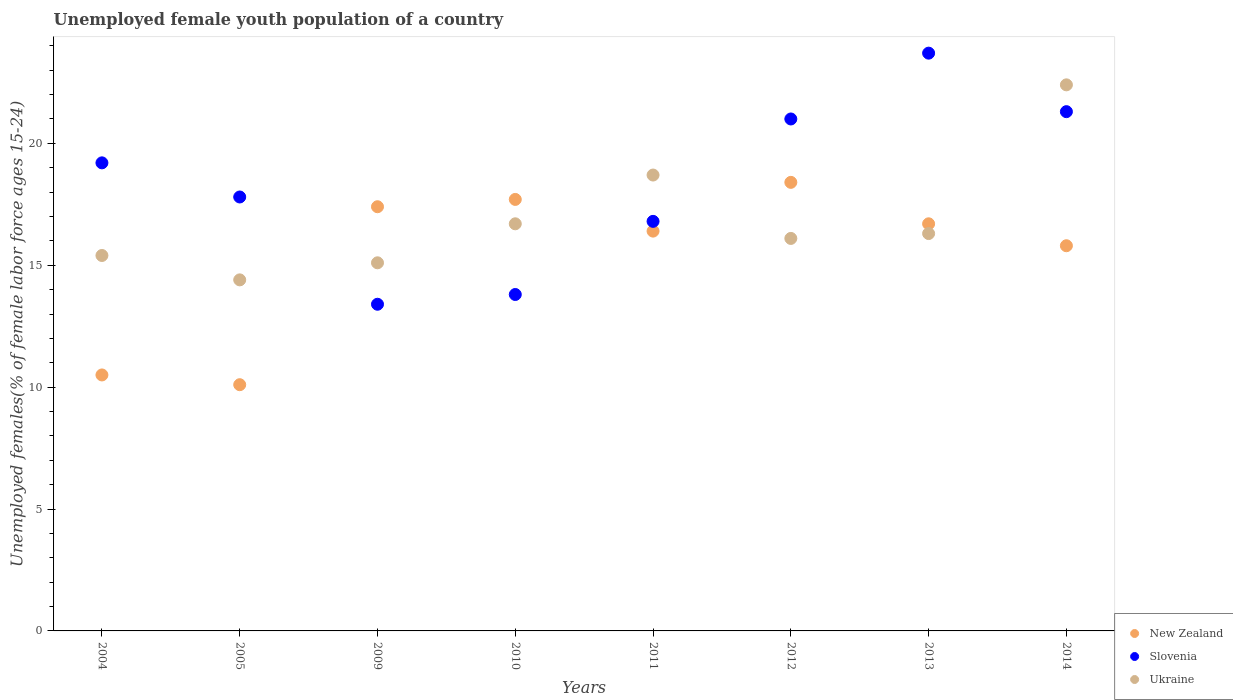How many different coloured dotlines are there?
Keep it short and to the point. 3. Is the number of dotlines equal to the number of legend labels?
Your answer should be very brief. Yes. What is the percentage of unemployed female youth population in Ukraine in 2013?
Give a very brief answer. 16.3. Across all years, what is the maximum percentage of unemployed female youth population in Slovenia?
Offer a terse response. 23.7. Across all years, what is the minimum percentage of unemployed female youth population in Slovenia?
Keep it short and to the point. 13.4. In which year was the percentage of unemployed female youth population in Slovenia maximum?
Provide a succinct answer. 2013. What is the total percentage of unemployed female youth population in Slovenia in the graph?
Give a very brief answer. 147. What is the difference between the percentage of unemployed female youth population in New Zealand in 2004 and that in 2011?
Your answer should be compact. -5.9. What is the difference between the percentage of unemployed female youth population in New Zealand in 2012 and the percentage of unemployed female youth population in Slovenia in 2010?
Give a very brief answer. 4.6. What is the average percentage of unemployed female youth population in New Zealand per year?
Keep it short and to the point. 15.38. In the year 2010, what is the difference between the percentage of unemployed female youth population in New Zealand and percentage of unemployed female youth population in Ukraine?
Provide a short and direct response. 1. In how many years, is the percentage of unemployed female youth population in Ukraine greater than 17 %?
Your answer should be compact. 2. What is the ratio of the percentage of unemployed female youth population in Ukraine in 2009 to that in 2012?
Give a very brief answer. 0.94. Is the percentage of unemployed female youth population in Ukraine in 2009 less than that in 2013?
Give a very brief answer. Yes. What is the difference between the highest and the second highest percentage of unemployed female youth population in Ukraine?
Your answer should be compact. 3.7. What is the difference between the highest and the lowest percentage of unemployed female youth population in New Zealand?
Your response must be concise. 8.3. Is the sum of the percentage of unemployed female youth population in Slovenia in 2012 and 2014 greater than the maximum percentage of unemployed female youth population in New Zealand across all years?
Ensure brevity in your answer.  Yes. Does the percentage of unemployed female youth population in Slovenia monotonically increase over the years?
Give a very brief answer. No. How many dotlines are there?
Provide a short and direct response. 3. Does the graph contain grids?
Your response must be concise. No. Where does the legend appear in the graph?
Your response must be concise. Bottom right. How are the legend labels stacked?
Keep it short and to the point. Vertical. What is the title of the graph?
Your response must be concise. Unemployed female youth population of a country. Does "Belize" appear as one of the legend labels in the graph?
Keep it short and to the point. No. What is the label or title of the X-axis?
Your answer should be very brief. Years. What is the label or title of the Y-axis?
Provide a succinct answer. Unemployed females(% of female labor force ages 15-24). What is the Unemployed females(% of female labor force ages 15-24) of New Zealand in 2004?
Offer a terse response. 10.5. What is the Unemployed females(% of female labor force ages 15-24) in Slovenia in 2004?
Offer a very short reply. 19.2. What is the Unemployed females(% of female labor force ages 15-24) of Ukraine in 2004?
Provide a succinct answer. 15.4. What is the Unemployed females(% of female labor force ages 15-24) of New Zealand in 2005?
Your answer should be compact. 10.1. What is the Unemployed females(% of female labor force ages 15-24) of Slovenia in 2005?
Give a very brief answer. 17.8. What is the Unemployed females(% of female labor force ages 15-24) of Ukraine in 2005?
Provide a succinct answer. 14.4. What is the Unemployed females(% of female labor force ages 15-24) of New Zealand in 2009?
Provide a short and direct response. 17.4. What is the Unemployed females(% of female labor force ages 15-24) of Slovenia in 2009?
Your answer should be very brief. 13.4. What is the Unemployed females(% of female labor force ages 15-24) of Ukraine in 2009?
Your response must be concise. 15.1. What is the Unemployed females(% of female labor force ages 15-24) of New Zealand in 2010?
Offer a terse response. 17.7. What is the Unemployed females(% of female labor force ages 15-24) of Slovenia in 2010?
Keep it short and to the point. 13.8. What is the Unemployed females(% of female labor force ages 15-24) in Ukraine in 2010?
Offer a terse response. 16.7. What is the Unemployed females(% of female labor force ages 15-24) of New Zealand in 2011?
Your response must be concise. 16.4. What is the Unemployed females(% of female labor force ages 15-24) in Slovenia in 2011?
Your answer should be very brief. 16.8. What is the Unemployed females(% of female labor force ages 15-24) of Ukraine in 2011?
Provide a succinct answer. 18.7. What is the Unemployed females(% of female labor force ages 15-24) in New Zealand in 2012?
Give a very brief answer. 18.4. What is the Unemployed females(% of female labor force ages 15-24) in Ukraine in 2012?
Offer a terse response. 16.1. What is the Unemployed females(% of female labor force ages 15-24) of New Zealand in 2013?
Your answer should be compact. 16.7. What is the Unemployed females(% of female labor force ages 15-24) of Slovenia in 2013?
Provide a short and direct response. 23.7. What is the Unemployed females(% of female labor force ages 15-24) of Ukraine in 2013?
Your answer should be compact. 16.3. What is the Unemployed females(% of female labor force ages 15-24) in New Zealand in 2014?
Provide a short and direct response. 15.8. What is the Unemployed females(% of female labor force ages 15-24) in Slovenia in 2014?
Your answer should be compact. 21.3. What is the Unemployed females(% of female labor force ages 15-24) in Ukraine in 2014?
Offer a terse response. 22.4. Across all years, what is the maximum Unemployed females(% of female labor force ages 15-24) in New Zealand?
Provide a succinct answer. 18.4. Across all years, what is the maximum Unemployed females(% of female labor force ages 15-24) of Slovenia?
Offer a very short reply. 23.7. Across all years, what is the maximum Unemployed females(% of female labor force ages 15-24) of Ukraine?
Make the answer very short. 22.4. Across all years, what is the minimum Unemployed females(% of female labor force ages 15-24) in New Zealand?
Your response must be concise. 10.1. Across all years, what is the minimum Unemployed females(% of female labor force ages 15-24) in Slovenia?
Offer a very short reply. 13.4. Across all years, what is the minimum Unemployed females(% of female labor force ages 15-24) of Ukraine?
Provide a succinct answer. 14.4. What is the total Unemployed females(% of female labor force ages 15-24) of New Zealand in the graph?
Offer a terse response. 123. What is the total Unemployed females(% of female labor force ages 15-24) in Slovenia in the graph?
Keep it short and to the point. 147. What is the total Unemployed females(% of female labor force ages 15-24) in Ukraine in the graph?
Ensure brevity in your answer.  135.1. What is the difference between the Unemployed females(% of female labor force ages 15-24) in Slovenia in 2004 and that in 2010?
Make the answer very short. 5.4. What is the difference between the Unemployed females(% of female labor force ages 15-24) in Slovenia in 2004 and that in 2012?
Offer a very short reply. -1.8. What is the difference between the Unemployed females(% of female labor force ages 15-24) of New Zealand in 2004 and that in 2013?
Offer a very short reply. -6.2. What is the difference between the Unemployed females(% of female labor force ages 15-24) in Slovenia in 2004 and that in 2013?
Ensure brevity in your answer.  -4.5. What is the difference between the Unemployed females(% of female labor force ages 15-24) of Ukraine in 2004 and that in 2013?
Give a very brief answer. -0.9. What is the difference between the Unemployed females(% of female labor force ages 15-24) in New Zealand in 2004 and that in 2014?
Offer a terse response. -5.3. What is the difference between the Unemployed females(% of female labor force ages 15-24) in Ukraine in 2004 and that in 2014?
Provide a succinct answer. -7. What is the difference between the Unemployed females(% of female labor force ages 15-24) of New Zealand in 2005 and that in 2009?
Ensure brevity in your answer.  -7.3. What is the difference between the Unemployed females(% of female labor force ages 15-24) in New Zealand in 2005 and that in 2010?
Your answer should be very brief. -7.6. What is the difference between the Unemployed females(% of female labor force ages 15-24) of Slovenia in 2005 and that in 2010?
Ensure brevity in your answer.  4. What is the difference between the Unemployed females(% of female labor force ages 15-24) in Slovenia in 2005 and that in 2011?
Provide a short and direct response. 1. What is the difference between the Unemployed females(% of female labor force ages 15-24) in Slovenia in 2005 and that in 2013?
Keep it short and to the point. -5.9. What is the difference between the Unemployed females(% of female labor force ages 15-24) of New Zealand in 2005 and that in 2014?
Make the answer very short. -5.7. What is the difference between the Unemployed females(% of female labor force ages 15-24) of Slovenia in 2005 and that in 2014?
Ensure brevity in your answer.  -3.5. What is the difference between the Unemployed females(% of female labor force ages 15-24) of Ukraine in 2005 and that in 2014?
Give a very brief answer. -8. What is the difference between the Unemployed females(% of female labor force ages 15-24) in Slovenia in 2009 and that in 2010?
Your response must be concise. -0.4. What is the difference between the Unemployed females(% of female labor force ages 15-24) in Ukraine in 2009 and that in 2011?
Keep it short and to the point. -3.6. What is the difference between the Unemployed females(% of female labor force ages 15-24) of New Zealand in 2009 and that in 2012?
Offer a very short reply. -1. What is the difference between the Unemployed females(% of female labor force ages 15-24) in New Zealand in 2009 and that in 2013?
Keep it short and to the point. 0.7. What is the difference between the Unemployed females(% of female labor force ages 15-24) in Slovenia in 2009 and that in 2013?
Give a very brief answer. -10.3. What is the difference between the Unemployed females(% of female labor force ages 15-24) in Slovenia in 2009 and that in 2014?
Your answer should be compact. -7.9. What is the difference between the Unemployed females(% of female labor force ages 15-24) of Ukraine in 2009 and that in 2014?
Provide a succinct answer. -7.3. What is the difference between the Unemployed females(% of female labor force ages 15-24) in Slovenia in 2010 and that in 2011?
Offer a very short reply. -3. What is the difference between the Unemployed females(% of female labor force ages 15-24) of New Zealand in 2010 and that in 2012?
Provide a succinct answer. -0.7. What is the difference between the Unemployed females(% of female labor force ages 15-24) of New Zealand in 2010 and that in 2013?
Provide a short and direct response. 1. What is the difference between the Unemployed females(% of female labor force ages 15-24) in Ukraine in 2010 and that in 2013?
Your response must be concise. 0.4. What is the difference between the Unemployed females(% of female labor force ages 15-24) of Slovenia in 2010 and that in 2014?
Keep it short and to the point. -7.5. What is the difference between the Unemployed females(% of female labor force ages 15-24) of Slovenia in 2011 and that in 2012?
Ensure brevity in your answer.  -4.2. What is the difference between the Unemployed females(% of female labor force ages 15-24) in Ukraine in 2011 and that in 2012?
Your answer should be very brief. 2.6. What is the difference between the Unemployed females(% of female labor force ages 15-24) in New Zealand in 2011 and that in 2013?
Make the answer very short. -0.3. What is the difference between the Unemployed females(% of female labor force ages 15-24) of Ukraine in 2011 and that in 2013?
Make the answer very short. 2.4. What is the difference between the Unemployed females(% of female labor force ages 15-24) in Ukraine in 2011 and that in 2014?
Make the answer very short. -3.7. What is the difference between the Unemployed females(% of female labor force ages 15-24) of Ukraine in 2012 and that in 2013?
Your answer should be very brief. -0.2. What is the difference between the Unemployed females(% of female labor force ages 15-24) of Slovenia in 2012 and that in 2014?
Your answer should be very brief. -0.3. What is the difference between the Unemployed females(% of female labor force ages 15-24) of Slovenia in 2013 and that in 2014?
Give a very brief answer. 2.4. What is the difference between the Unemployed females(% of female labor force ages 15-24) of Ukraine in 2013 and that in 2014?
Provide a succinct answer. -6.1. What is the difference between the Unemployed females(% of female labor force ages 15-24) of New Zealand in 2004 and the Unemployed females(% of female labor force ages 15-24) of Ukraine in 2005?
Provide a succinct answer. -3.9. What is the difference between the Unemployed females(% of female labor force ages 15-24) in New Zealand in 2004 and the Unemployed females(% of female labor force ages 15-24) in Slovenia in 2009?
Offer a very short reply. -2.9. What is the difference between the Unemployed females(% of female labor force ages 15-24) of New Zealand in 2004 and the Unemployed females(% of female labor force ages 15-24) of Ukraine in 2009?
Make the answer very short. -4.6. What is the difference between the Unemployed females(% of female labor force ages 15-24) of New Zealand in 2004 and the Unemployed females(% of female labor force ages 15-24) of Ukraine in 2010?
Provide a succinct answer. -6.2. What is the difference between the Unemployed females(% of female labor force ages 15-24) of Slovenia in 2004 and the Unemployed females(% of female labor force ages 15-24) of Ukraine in 2010?
Your answer should be very brief. 2.5. What is the difference between the Unemployed females(% of female labor force ages 15-24) of New Zealand in 2004 and the Unemployed females(% of female labor force ages 15-24) of Slovenia in 2011?
Provide a succinct answer. -6.3. What is the difference between the Unemployed females(% of female labor force ages 15-24) of Slovenia in 2004 and the Unemployed females(% of female labor force ages 15-24) of Ukraine in 2011?
Make the answer very short. 0.5. What is the difference between the Unemployed females(% of female labor force ages 15-24) of New Zealand in 2004 and the Unemployed females(% of female labor force ages 15-24) of Slovenia in 2012?
Your answer should be very brief. -10.5. What is the difference between the Unemployed females(% of female labor force ages 15-24) in New Zealand in 2004 and the Unemployed females(% of female labor force ages 15-24) in Ukraine in 2012?
Provide a short and direct response. -5.6. What is the difference between the Unemployed females(% of female labor force ages 15-24) of New Zealand in 2004 and the Unemployed females(% of female labor force ages 15-24) of Slovenia in 2013?
Provide a short and direct response. -13.2. What is the difference between the Unemployed females(% of female labor force ages 15-24) of New Zealand in 2005 and the Unemployed females(% of female labor force ages 15-24) of Ukraine in 2009?
Give a very brief answer. -5. What is the difference between the Unemployed females(% of female labor force ages 15-24) in Slovenia in 2005 and the Unemployed females(% of female labor force ages 15-24) in Ukraine in 2009?
Keep it short and to the point. 2.7. What is the difference between the Unemployed females(% of female labor force ages 15-24) in New Zealand in 2005 and the Unemployed females(% of female labor force ages 15-24) in Slovenia in 2010?
Keep it short and to the point. -3.7. What is the difference between the Unemployed females(% of female labor force ages 15-24) of New Zealand in 2005 and the Unemployed females(% of female labor force ages 15-24) of Ukraine in 2010?
Give a very brief answer. -6.6. What is the difference between the Unemployed females(% of female labor force ages 15-24) in Slovenia in 2005 and the Unemployed females(% of female labor force ages 15-24) in Ukraine in 2010?
Give a very brief answer. 1.1. What is the difference between the Unemployed females(% of female labor force ages 15-24) of New Zealand in 2005 and the Unemployed females(% of female labor force ages 15-24) of Slovenia in 2011?
Offer a very short reply. -6.7. What is the difference between the Unemployed females(% of female labor force ages 15-24) of New Zealand in 2005 and the Unemployed females(% of female labor force ages 15-24) of Ukraine in 2011?
Give a very brief answer. -8.6. What is the difference between the Unemployed females(% of female labor force ages 15-24) of Slovenia in 2005 and the Unemployed females(% of female labor force ages 15-24) of Ukraine in 2011?
Keep it short and to the point. -0.9. What is the difference between the Unemployed females(% of female labor force ages 15-24) of New Zealand in 2005 and the Unemployed females(% of female labor force ages 15-24) of Slovenia in 2014?
Your answer should be compact. -11.2. What is the difference between the Unemployed females(% of female labor force ages 15-24) in New Zealand in 2005 and the Unemployed females(% of female labor force ages 15-24) in Ukraine in 2014?
Offer a terse response. -12.3. What is the difference between the Unemployed females(% of female labor force ages 15-24) of Slovenia in 2005 and the Unemployed females(% of female labor force ages 15-24) of Ukraine in 2014?
Give a very brief answer. -4.6. What is the difference between the Unemployed females(% of female labor force ages 15-24) in New Zealand in 2009 and the Unemployed females(% of female labor force ages 15-24) in Slovenia in 2010?
Your answer should be very brief. 3.6. What is the difference between the Unemployed females(% of female labor force ages 15-24) in New Zealand in 2009 and the Unemployed females(% of female labor force ages 15-24) in Slovenia in 2011?
Offer a terse response. 0.6. What is the difference between the Unemployed females(% of female labor force ages 15-24) of New Zealand in 2009 and the Unemployed females(% of female labor force ages 15-24) of Ukraine in 2011?
Give a very brief answer. -1.3. What is the difference between the Unemployed females(% of female labor force ages 15-24) in Slovenia in 2009 and the Unemployed females(% of female labor force ages 15-24) in Ukraine in 2012?
Your answer should be compact. -2.7. What is the difference between the Unemployed females(% of female labor force ages 15-24) of New Zealand in 2009 and the Unemployed females(% of female labor force ages 15-24) of Slovenia in 2013?
Ensure brevity in your answer.  -6.3. What is the difference between the Unemployed females(% of female labor force ages 15-24) in New Zealand in 2009 and the Unemployed females(% of female labor force ages 15-24) in Ukraine in 2013?
Your response must be concise. 1.1. What is the difference between the Unemployed females(% of female labor force ages 15-24) of Slovenia in 2009 and the Unemployed females(% of female labor force ages 15-24) of Ukraine in 2013?
Offer a terse response. -2.9. What is the difference between the Unemployed females(% of female labor force ages 15-24) of New Zealand in 2009 and the Unemployed females(% of female labor force ages 15-24) of Slovenia in 2014?
Give a very brief answer. -3.9. What is the difference between the Unemployed females(% of female labor force ages 15-24) in New Zealand in 2010 and the Unemployed females(% of female labor force ages 15-24) in Slovenia in 2011?
Your response must be concise. 0.9. What is the difference between the Unemployed females(% of female labor force ages 15-24) in New Zealand in 2010 and the Unemployed females(% of female labor force ages 15-24) in Ukraine in 2012?
Ensure brevity in your answer.  1.6. What is the difference between the Unemployed females(% of female labor force ages 15-24) in Slovenia in 2010 and the Unemployed females(% of female labor force ages 15-24) in Ukraine in 2012?
Provide a succinct answer. -2.3. What is the difference between the Unemployed females(% of female labor force ages 15-24) in New Zealand in 2010 and the Unemployed females(% of female labor force ages 15-24) in Ukraine in 2013?
Offer a very short reply. 1.4. What is the difference between the Unemployed females(% of female labor force ages 15-24) of New Zealand in 2010 and the Unemployed females(% of female labor force ages 15-24) of Ukraine in 2014?
Keep it short and to the point. -4.7. What is the difference between the Unemployed females(% of female labor force ages 15-24) in Slovenia in 2010 and the Unemployed females(% of female labor force ages 15-24) in Ukraine in 2014?
Your answer should be very brief. -8.6. What is the difference between the Unemployed females(% of female labor force ages 15-24) of New Zealand in 2011 and the Unemployed females(% of female labor force ages 15-24) of Ukraine in 2012?
Provide a succinct answer. 0.3. What is the difference between the Unemployed females(% of female labor force ages 15-24) of Slovenia in 2011 and the Unemployed females(% of female labor force ages 15-24) of Ukraine in 2012?
Provide a short and direct response. 0.7. What is the difference between the Unemployed females(% of female labor force ages 15-24) in New Zealand in 2011 and the Unemployed females(% of female labor force ages 15-24) in Slovenia in 2013?
Your response must be concise. -7.3. What is the difference between the Unemployed females(% of female labor force ages 15-24) in New Zealand in 2011 and the Unemployed females(% of female labor force ages 15-24) in Ukraine in 2013?
Provide a succinct answer. 0.1. What is the difference between the Unemployed females(% of female labor force ages 15-24) in Slovenia in 2011 and the Unemployed females(% of female labor force ages 15-24) in Ukraine in 2013?
Provide a succinct answer. 0.5. What is the difference between the Unemployed females(% of female labor force ages 15-24) in New Zealand in 2011 and the Unemployed females(% of female labor force ages 15-24) in Slovenia in 2014?
Offer a terse response. -4.9. What is the difference between the Unemployed females(% of female labor force ages 15-24) of New Zealand in 2011 and the Unemployed females(% of female labor force ages 15-24) of Ukraine in 2014?
Ensure brevity in your answer.  -6. What is the difference between the Unemployed females(% of female labor force ages 15-24) of Slovenia in 2011 and the Unemployed females(% of female labor force ages 15-24) of Ukraine in 2014?
Your answer should be compact. -5.6. What is the difference between the Unemployed females(% of female labor force ages 15-24) in New Zealand in 2012 and the Unemployed females(% of female labor force ages 15-24) in Slovenia in 2013?
Give a very brief answer. -5.3. What is the difference between the Unemployed females(% of female labor force ages 15-24) of Slovenia in 2012 and the Unemployed females(% of female labor force ages 15-24) of Ukraine in 2013?
Give a very brief answer. 4.7. What is the difference between the Unemployed females(% of female labor force ages 15-24) of New Zealand in 2012 and the Unemployed females(% of female labor force ages 15-24) of Slovenia in 2014?
Offer a terse response. -2.9. What is the difference between the Unemployed females(% of female labor force ages 15-24) in New Zealand in 2012 and the Unemployed females(% of female labor force ages 15-24) in Ukraine in 2014?
Provide a succinct answer. -4. What is the difference between the Unemployed females(% of female labor force ages 15-24) in New Zealand in 2013 and the Unemployed females(% of female labor force ages 15-24) in Slovenia in 2014?
Give a very brief answer. -4.6. What is the average Unemployed females(% of female labor force ages 15-24) of New Zealand per year?
Make the answer very short. 15.38. What is the average Unemployed females(% of female labor force ages 15-24) in Slovenia per year?
Your answer should be compact. 18.38. What is the average Unemployed females(% of female labor force ages 15-24) of Ukraine per year?
Ensure brevity in your answer.  16.89. In the year 2005, what is the difference between the Unemployed females(% of female labor force ages 15-24) in Slovenia and Unemployed females(% of female labor force ages 15-24) in Ukraine?
Your response must be concise. 3.4. In the year 2009, what is the difference between the Unemployed females(% of female labor force ages 15-24) of New Zealand and Unemployed females(% of female labor force ages 15-24) of Slovenia?
Your response must be concise. 4. In the year 2009, what is the difference between the Unemployed females(% of female labor force ages 15-24) of New Zealand and Unemployed females(% of female labor force ages 15-24) of Ukraine?
Provide a short and direct response. 2.3. In the year 2009, what is the difference between the Unemployed females(% of female labor force ages 15-24) in Slovenia and Unemployed females(% of female labor force ages 15-24) in Ukraine?
Keep it short and to the point. -1.7. In the year 2011, what is the difference between the Unemployed females(% of female labor force ages 15-24) in New Zealand and Unemployed females(% of female labor force ages 15-24) in Slovenia?
Make the answer very short. -0.4. In the year 2013, what is the difference between the Unemployed females(% of female labor force ages 15-24) of New Zealand and Unemployed females(% of female labor force ages 15-24) of Slovenia?
Keep it short and to the point. -7. In the year 2014, what is the difference between the Unemployed females(% of female labor force ages 15-24) of Slovenia and Unemployed females(% of female labor force ages 15-24) of Ukraine?
Make the answer very short. -1.1. What is the ratio of the Unemployed females(% of female labor force ages 15-24) of New Zealand in 2004 to that in 2005?
Your response must be concise. 1.04. What is the ratio of the Unemployed females(% of female labor force ages 15-24) in Slovenia in 2004 to that in 2005?
Ensure brevity in your answer.  1.08. What is the ratio of the Unemployed females(% of female labor force ages 15-24) of Ukraine in 2004 to that in 2005?
Provide a short and direct response. 1.07. What is the ratio of the Unemployed females(% of female labor force ages 15-24) of New Zealand in 2004 to that in 2009?
Offer a very short reply. 0.6. What is the ratio of the Unemployed females(% of female labor force ages 15-24) of Slovenia in 2004 to that in 2009?
Offer a terse response. 1.43. What is the ratio of the Unemployed females(% of female labor force ages 15-24) in Ukraine in 2004 to that in 2009?
Give a very brief answer. 1.02. What is the ratio of the Unemployed females(% of female labor force ages 15-24) in New Zealand in 2004 to that in 2010?
Your answer should be very brief. 0.59. What is the ratio of the Unemployed females(% of female labor force ages 15-24) of Slovenia in 2004 to that in 2010?
Provide a short and direct response. 1.39. What is the ratio of the Unemployed females(% of female labor force ages 15-24) in Ukraine in 2004 to that in 2010?
Your answer should be very brief. 0.92. What is the ratio of the Unemployed females(% of female labor force ages 15-24) of New Zealand in 2004 to that in 2011?
Make the answer very short. 0.64. What is the ratio of the Unemployed females(% of female labor force ages 15-24) in Ukraine in 2004 to that in 2011?
Provide a succinct answer. 0.82. What is the ratio of the Unemployed females(% of female labor force ages 15-24) in New Zealand in 2004 to that in 2012?
Offer a very short reply. 0.57. What is the ratio of the Unemployed females(% of female labor force ages 15-24) in Slovenia in 2004 to that in 2012?
Your answer should be very brief. 0.91. What is the ratio of the Unemployed females(% of female labor force ages 15-24) of Ukraine in 2004 to that in 2012?
Offer a very short reply. 0.96. What is the ratio of the Unemployed females(% of female labor force ages 15-24) of New Zealand in 2004 to that in 2013?
Your answer should be compact. 0.63. What is the ratio of the Unemployed females(% of female labor force ages 15-24) in Slovenia in 2004 to that in 2013?
Ensure brevity in your answer.  0.81. What is the ratio of the Unemployed females(% of female labor force ages 15-24) in Ukraine in 2004 to that in 2013?
Provide a succinct answer. 0.94. What is the ratio of the Unemployed females(% of female labor force ages 15-24) of New Zealand in 2004 to that in 2014?
Keep it short and to the point. 0.66. What is the ratio of the Unemployed females(% of female labor force ages 15-24) in Slovenia in 2004 to that in 2014?
Your response must be concise. 0.9. What is the ratio of the Unemployed females(% of female labor force ages 15-24) in Ukraine in 2004 to that in 2014?
Your response must be concise. 0.69. What is the ratio of the Unemployed females(% of female labor force ages 15-24) in New Zealand in 2005 to that in 2009?
Your answer should be very brief. 0.58. What is the ratio of the Unemployed females(% of female labor force ages 15-24) of Slovenia in 2005 to that in 2009?
Your response must be concise. 1.33. What is the ratio of the Unemployed females(% of female labor force ages 15-24) of Ukraine in 2005 to that in 2009?
Your answer should be compact. 0.95. What is the ratio of the Unemployed females(% of female labor force ages 15-24) in New Zealand in 2005 to that in 2010?
Your answer should be compact. 0.57. What is the ratio of the Unemployed females(% of female labor force ages 15-24) in Slovenia in 2005 to that in 2010?
Your response must be concise. 1.29. What is the ratio of the Unemployed females(% of female labor force ages 15-24) of Ukraine in 2005 to that in 2010?
Your response must be concise. 0.86. What is the ratio of the Unemployed females(% of female labor force ages 15-24) of New Zealand in 2005 to that in 2011?
Give a very brief answer. 0.62. What is the ratio of the Unemployed females(% of female labor force ages 15-24) in Slovenia in 2005 to that in 2011?
Your answer should be compact. 1.06. What is the ratio of the Unemployed females(% of female labor force ages 15-24) in Ukraine in 2005 to that in 2011?
Provide a short and direct response. 0.77. What is the ratio of the Unemployed females(% of female labor force ages 15-24) in New Zealand in 2005 to that in 2012?
Offer a terse response. 0.55. What is the ratio of the Unemployed females(% of female labor force ages 15-24) of Slovenia in 2005 to that in 2012?
Offer a terse response. 0.85. What is the ratio of the Unemployed females(% of female labor force ages 15-24) of Ukraine in 2005 to that in 2012?
Make the answer very short. 0.89. What is the ratio of the Unemployed females(% of female labor force ages 15-24) in New Zealand in 2005 to that in 2013?
Provide a succinct answer. 0.6. What is the ratio of the Unemployed females(% of female labor force ages 15-24) of Slovenia in 2005 to that in 2013?
Give a very brief answer. 0.75. What is the ratio of the Unemployed females(% of female labor force ages 15-24) of Ukraine in 2005 to that in 2013?
Provide a short and direct response. 0.88. What is the ratio of the Unemployed females(% of female labor force ages 15-24) in New Zealand in 2005 to that in 2014?
Offer a very short reply. 0.64. What is the ratio of the Unemployed females(% of female labor force ages 15-24) in Slovenia in 2005 to that in 2014?
Your answer should be compact. 0.84. What is the ratio of the Unemployed females(% of female labor force ages 15-24) in Ukraine in 2005 to that in 2014?
Your answer should be very brief. 0.64. What is the ratio of the Unemployed females(% of female labor force ages 15-24) in New Zealand in 2009 to that in 2010?
Give a very brief answer. 0.98. What is the ratio of the Unemployed females(% of female labor force ages 15-24) of Slovenia in 2009 to that in 2010?
Keep it short and to the point. 0.97. What is the ratio of the Unemployed females(% of female labor force ages 15-24) in Ukraine in 2009 to that in 2010?
Offer a terse response. 0.9. What is the ratio of the Unemployed females(% of female labor force ages 15-24) of New Zealand in 2009 to that in 2011?
Your response must be concise. 1.06. What is the ratio of the Unemployed females(% of female labor force ages 15-24) in Slovenia in 2009 to that in 2011?
Your answer should be very brief. 0.8. What is the ratio of the Unemployed females(% of female labor force ages 15-24) of Ukraine in 2009 to that in 2011?
Provide a succinct answer. 0.81. What is the ratio of the Unemployed females(% of female labor force ages 15-24) of New Zealand in 2009 to that in 2012?
Offer a very short reply. 0.95. What is the ratio of the Unemployed females(% of female labor force ages 15-24) of Slovenia in 2009 to that in 2012?
Your answer should be very brief. 0.64. What is the ratio of the Unemployed females(% of female labor force ages 15-24) in Ukraine in 2009 to that in 2012?
Your response must be concise. 0.94. What is the ratio of the Unemployed females(% of female labor force ages 15-24) in New Zealand in 2009 to that in 2013?
Your answer should be compact. 1.04. What is the ratio of the Unemployed females(% of female labor force ages 15-24) of Slovenia in 2009 to that in 2013?
Offer a terse response. 0.57. What is the ratio of the Unemployed females(% of female labor force ages 15-24) in Ukraine in 2009 to that in 2013?
Your answer should be compact. 0.93. What is the ratio of the Unemployed females(% of female labor force ages 15-24) in New Zealand in 2009 to that in 2014?
Your answer should be compact. 1.1. What is the ratio of the Unemployed females(% of female labor force ages 15-24) of Slovenia in 2009 to that in 2014?
Offer a very short reply. 0.63. What is the ratio of the Unemployed females(% of female labor force ages 15-24) of Ukraine in 2009 to that in 2014?
Provide a succinct answer. 0.67. What is the ratio of the Unemployed females(% of female labor force ages 15-24) in New Zealand in 2010 to that in 2011?
Provide a short and direct response. 1.08. What is the ratio of the Unemployed females(% of female labor force ages 15-24) in Slovenia in 2010 to that in 2011?
Your answer should be very brief. 0.82. What is the ratio of the Unemployed females(% of female labor force ages 15-24) in Ukraine in 2010 to that in 2011?
Give a very brief answer. 0.89. What is the ratio of the Unemployed females(% of female labor force ages 15-24) of Slovenia in 2010 to that in 2012?
Make the answer very short. 0.66. What is the ratio of the Unemployed females(% of female labor force ages 15-24) of Ukraine in 2010 to that in 2012?
Offer a very short reply. 1.04. What is the ratio of the Unemployed females(% of female labor force ages 15-24) in New Zealand in 2010 to that in 2013?
Your response must be concise. 1.06. What is the ratio of the Unemployed females(% of female labor force ages 15-24) of Slovenia in 2010 to that in 2013?
Provide a succinct answer. 0.58. What is the ratio of the Unemployed females(% of female labor force ages 15-24) in Ukraine in 2010 to that in 2013?
Ensure brevity in your answer.  1.02. What is the ratio of the Unemployed females(% of female labor force ages 15-24) in New Zealand in 2010 to that in 2014?
Offer a terse response. 1.12. What is the ratio of the Unemployed females(% of female labor force ages 15-24) in Slovenia in 2010 to that in 2014?
Your answer should be very brief. 0.65. What is the ratio of the Unemployed females(% of female labor force ages 15-24) of Ukraine in 2010 to that in 2014?
Provide a succinct answer. 0.75. What is the ratio of the Unemployed females(% of female labor force ages 15-24) of New Zealand in 2011 to that in 2012?
Make the answer very short. 0.89. What is the ratio of the Unemployed females(% of female labor force ages 15-24) in Slovenia in 2011 to that in 2012?
Your response must be concise. 0.8. What is the ratio of the Unemployed females(% of female labor force ages 15-24) in Ukraine in 2011 to that in 2012?
Make the answer very short. 1.16. What is the ratio of the Unemployed females(% of female labor force ages 15-24) in Slovenia in 2011 to that in 2013?
Offer a terse response. 0.71. What is the ratio of the Unemployed females(% of female labor force ages 15-24) of Ukraine in 2011 to that in 2013?
Your answer should be compact. 1.15. What is the ratio of the Unemployed females(% of female labor force ages 15-24) in New Zealand in 2011 to that in 2014?
Offer a terse response. 1.04. What is the ratio of the Unemployed females(% of female labor force ages 15-24) in Slovenia in 2011 to that in 2014?
Make the answer very short. 0.79. What is the ratio of the Unemployed females(% of female labor force ages 15-24) in Ukraine in 2011 to that in 2014?
Ensure brevity in your answer.  0.83. What is the ratio of the Unemployed females(% of female labor force ages 15-24) of New Zealand in 2012 to that in 2013?
Your answer should be very brief. 1.1. What is the ratio of the Unemployed females(% of female labor force ages 15-24) of Slovenia in 2012 to that in 2013?
Ensure brevity in your answer.  0.89. What is the ratio of the Unemployed females(% of female labor force ages 15-24) in New Zealand in 2012 to that in 2014?
Your answer should be compact. 1.16. What is the ratio of the Unemployed females(% of female labor force ages 15-24) of Slovenia in 2012 to that in 2014?
Give a very brief answer. 0.99. What is the ratio of the Unemployed females(% of female labor force ages 15-24) in Ukraine in 2012 to that in 2014?
Your answer should be very brief. 0.72. What is the ratio of the Unemployed females(% of female labor force ages 15-24) in New Zealand in 2013 to that in 2014?
Offer a very short reply. 1.06. What is the ratio of the Unemployed females(% of female labor force ages 15-24) of Slovenia in 2013 to that in 2014?
Provide a short and direct response. 1.11. What is the ratio of the Unemployed females(% of female labor force ages 15-24) of Ukraine in 2013 to that in 2014?
Provide a succinct answer. 0.73. What is the difference between the highest and the second highest Unemployed females(% of female labor force ages 15-24) of New Zealand?
Offer a terse response. 0.7. What is the difference between the highest and the lowest Unemployed females(% of female labor force ages 15-24) in New Zealand?
Make the answer very short. 8.3. What is the difference between the highest and the lowest Unemployed females(% of female labor force ages 15-24) of Slovenia?
Offer a terse response. 10.3. 